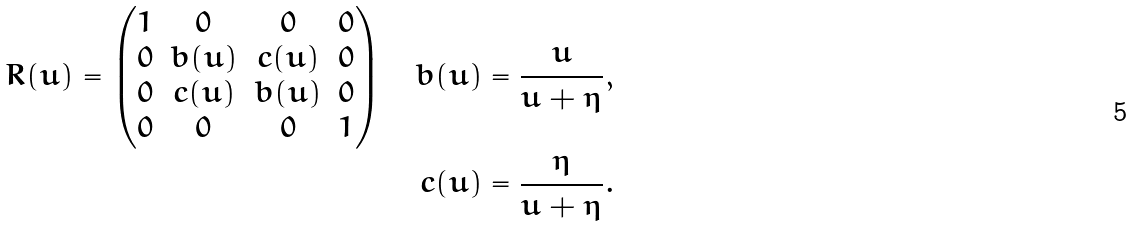<formula> <loc_0><loc_0><loc_500><loc_500>R ( u ) = \begin{pmatrix} 1 & 0 & 0 & 0 \\ 0 & b ( u ) & c ( u ) & 0 \\ 0 & c ( u ) & b ( u ) & 0 \\ 0 & 0 & 0 & 1 \end{pmatrix} \quad b ( u ) & = \frac { u } { u + \eta } , \\ c ( u ) & = \frac { \eta } { u + \eta } .</formula> 